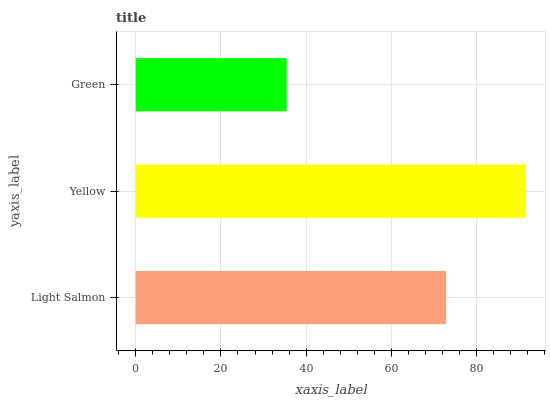Is Green the minimum?
Answer yes or no. Yes. Is Yellow the maximum?
Answer yes or no. Yes. Is Yellow the minimum?
Answer yes or no. No. Is Green the maximum?
Answer yes or no. No. Is Yellow greater than Green?
Answer yes or no. Yes. Is Green less than Yellow?
Answer yes or no. Yes. Is Green greater than Yellow?
Answer yes or no. No. Is Yellow less than Green?
Answer yes or no. No. Is Light Salmon the high median?
Answer yes or no. Yes. Is Light Salmon the low median?
Answer yes or no. Yes. Is Green the high median?
Answer yes or no. No. Is Green the low median?
Answer yes or no. No. 